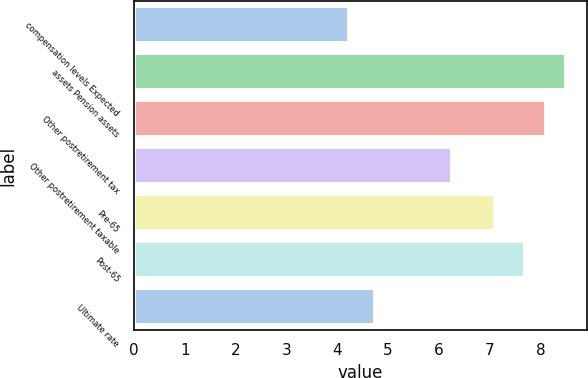Convert chart. <chart><loc_0><loc_0><loc_500><loc_500><bar_chart><fcel>compensation levels Expected<fcel>assets Pension assets<fcel>Other postretirement tax<fcel>Other postretirement taxable<fcel>Pre-65<fcel>Post-65<fcel>Ultimate rate<nl><fcel>4.23<fcel>8.5<fcel>8.1<fcel>6.25<fcel>7.1<fcel>7.7<fcel>4.75<nl></chart> 